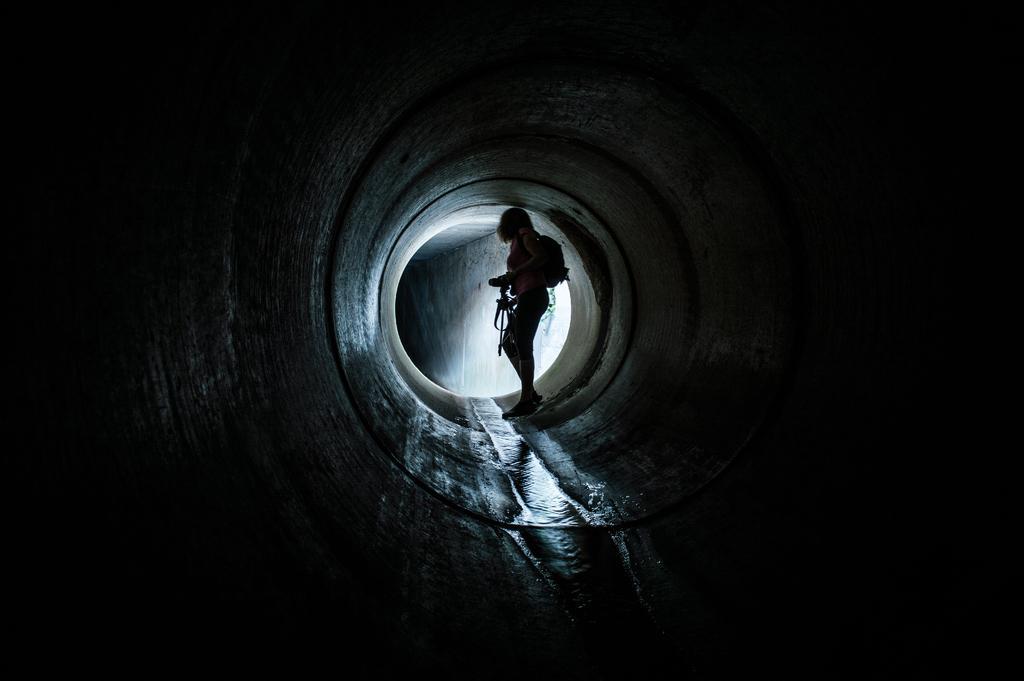Could you give a brief overview of what you see in this image? In this picture I can see a human standing and holding a camera in the hand and a backpack on the back and I can see water. 